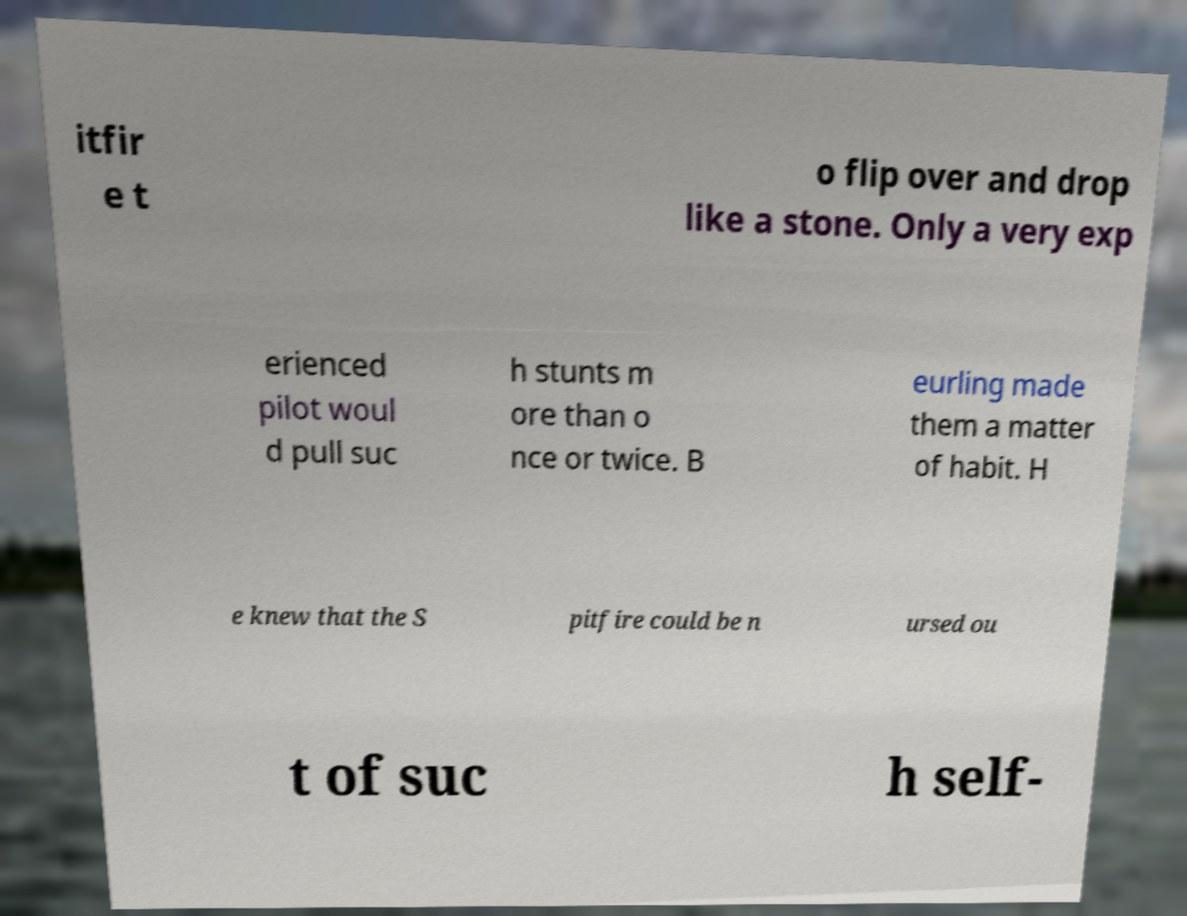I need the written content from this picture converted into text. Can you do that? itfir e t o flip over and drop like a stone. Only a very exp erienced pilot woul d pull suc h stunts m ore than o nce or twice. B eurling made them a matter of habit. H e knew that the S pitfire could be n ursed ou t of suc h self- 